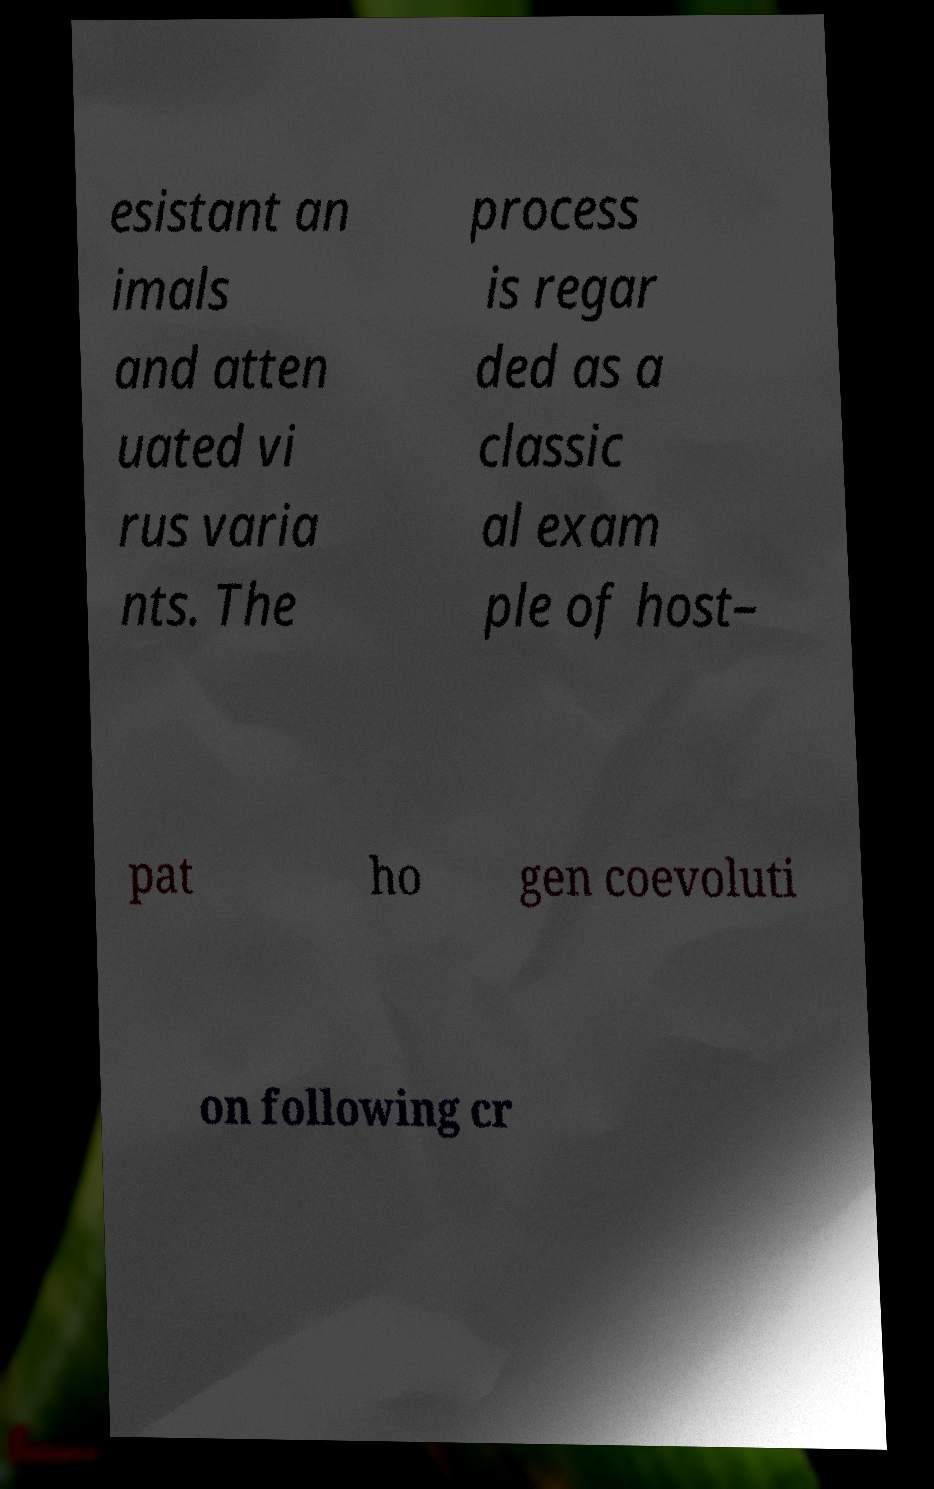For documentation purposes, I need the text within this image transcribed. Could you provide that? esistant an imals and atten uated vi rus varia nts. The process is regar ded as a classic al exam ple of host– pat ho gen coevoluti on following cr 